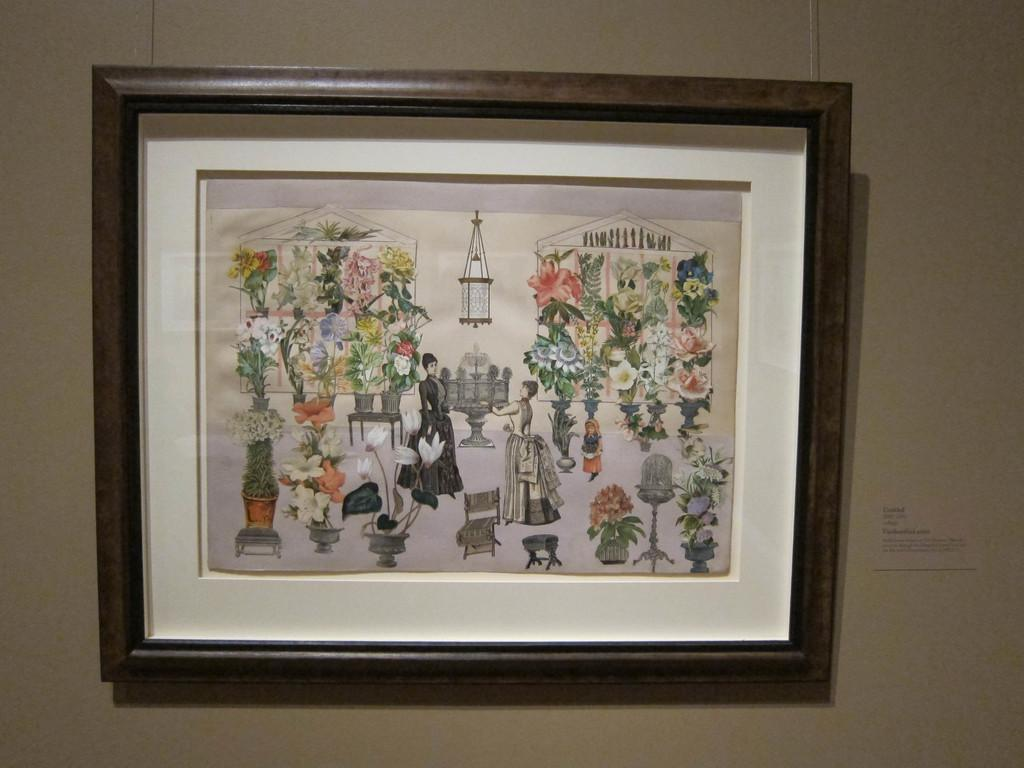What object can be seen in the image that is typically used for displaying photos? There is a photo frame in the image. Where is the photo frame located? The photo frame is on a wall. What type of sail can be seen in the image? There is no sail present in the image. What type of lace is used to decorate the photo frame in the image? The photo frame in the image does not have any lace decoration. 